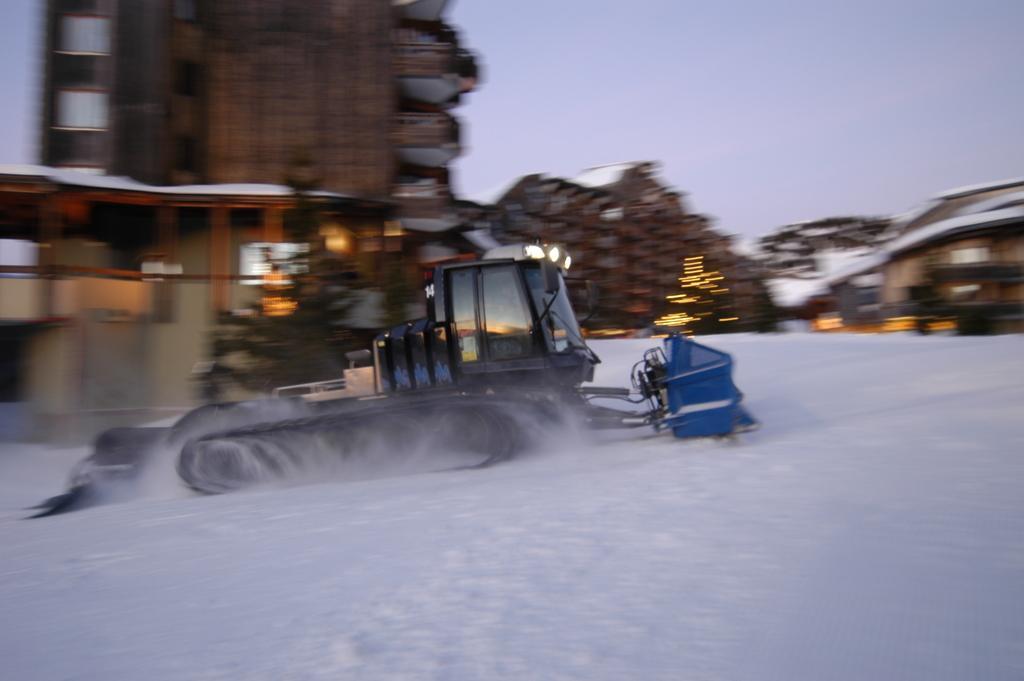Please provide a concise description of this image. In this image I can see the vehicle on the snow. In the background I can see many buildings, lights and the sky. But the background is blurry. 